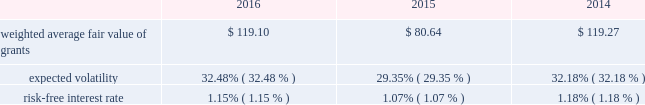Weighted average fair values and valuation assumptions used to value performance unit and performance stock grants during the years ended december 31 , 2016 , 2015 and 2014 were as follows: .
Expected volatility is based on the term-matched historical volatility over the simulated term , which is calculated as the time between the grant date and the end of the performance period .
The risk-free interest rate is based on a 3.25 year zero-coupon risk-free interest rate derived from the treasury constant maturities yield curve on the grant date .
At december 31 , 2016 , unrecognized compensation expense related to performance units totaled $ 10 million .
Such unrecognized expense will be amortized on a straight-line basis over a weighted average period of 3.0 years .
Pension plans .
Eog has a defined contribution pension plan in place for most of its employees in the united states .
Eog's contributions to the pension plan are based on various percentages of compensation and , in some instances , are based upon the amount of the employees' contributions .
Eog's total costs recognized for the plan were $ 34 million , $ 36 million and $ 41 million for 2016 , 2015 and 2014 , respectively .
In addition , eog's trinidadian subsidiary maintains a contributory defined benefit pension plan and a matched savings plan .
Eog's united kingdom subsidiary maintains a pension plan which includes a non-contributory defined contribution pension plan and a matched defined contribution savings plan .
These pension plans are available to most employees of the trinidadian and united kingdom subsidiaries .
Eog's combined contributions to these plans were $ 1 million , $ 1 million and $ 5 million for 2016 , 2015 and 2014 , respectively .
For the trinidadian defined benefit pension plan , the benefit obligation , fair value of plan assets and accrued benefit cost totaled $ 8 million , $ 7 million and $ 0.3 million , respectively , at december 31 , 2016 , and $ 9 million , $ 7 million and $ 0.2 million , respectively , at december 31 , 2015 .
In connection with the divestiture of substantially all of its canadian assets in the fourth quarter of 2014 , eog has elected to terminate the canadian non-contributory defined benefit pension plan .
Postretirement health care .
Eog has postretirement medical and dental benefits in place for eligible united states and trinidad employees and their eligible dependents , the costs of which are not material .
Commitments and contingencies letters of credit and guarantees .
At december 31 , 2016 and 2015 , respectively , eog had standby letters of credit and guarantees outstanding totaling approximately $ 226 million and $ 272 million , primarily representing guarantees of payment or performance obligations on behalf of subsidiaries .
As of february 20 , 2017 , there were no demands for payment under these guarantees. .
What is the variation observed in the risk-free interest rate during 2015 and 2016? 
Rationale: it is the difference between those risk-free interest rates .
Computations: (1.15% - 1.07%)
Answer: 0.0008. 